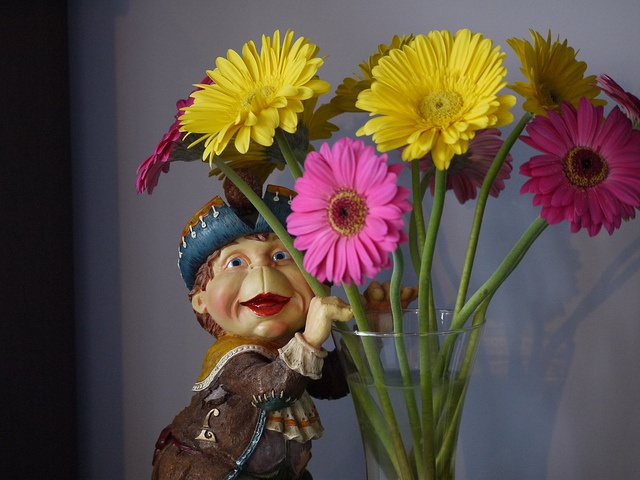Describe the objects in this image and their specific colors. I can see a vase in black, darkgreen, and purple tones in this image. 